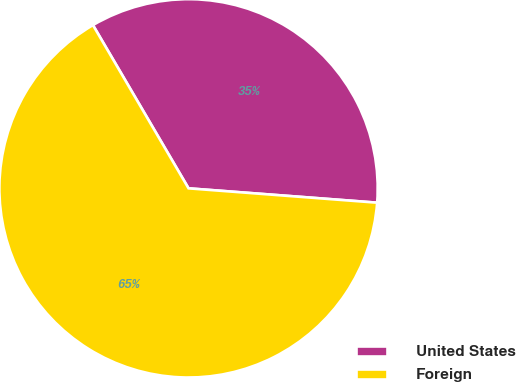Convert chart. <chart><loc_0><loc_0><loc_500><loc_500><pie_chart><fcel>United States<fcel>Foreign<nl><fcel>34.64%<fcel>65.36%<nl></chart> 